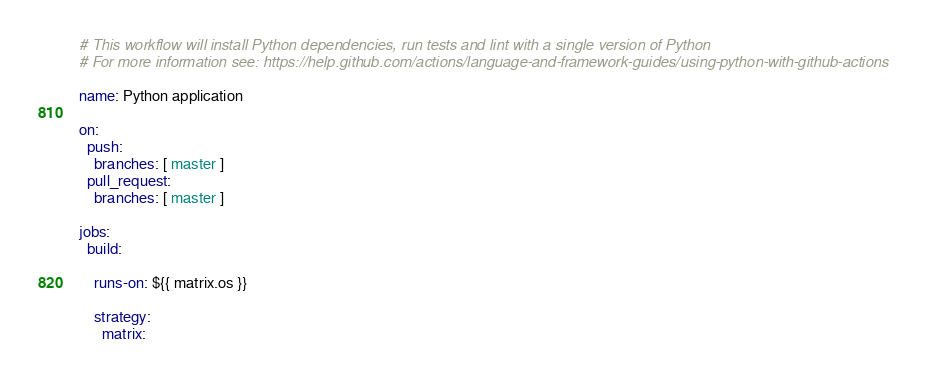<code> <loc_0><loc_0><loc_500><loc_500><_YAML_># This workflow will install Python dependencies, run tests and lint with a single version of Python
# For more information see: https://help.github.com/actions/language-and-framework-guides/using-python-with-github-actions

name: Python application

on:
  push:
    branches: [ master ]
  pull_request:
    branches: [ master ]

jobs:
  build:

    runs-on: ${{ matrix.os }}

    strategy:
      matrix:</code> 